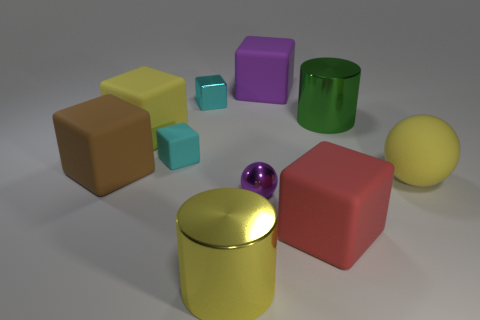Subtract all red blocks. How many blocks are left? 5 Subtract 2 blocks. How many blocks are left? 4 Subtract all large yellow matte cubes. How many cubes are left? 5 Subtract all gray blocks. Subtract all blue cylinders. How many blocks are left? 6 Subtract all balls. How many objects are left? 8 Add 6 large green metal cylinders. How many large green metal cylinders are left? 7 Add 5 balls. How many balls exist? 7 Subtract 0 brown cylinders. How many objects are left? 10 Subtract all yellow spheres. Subtract all small purple metal balls. How many objects are left? 8 